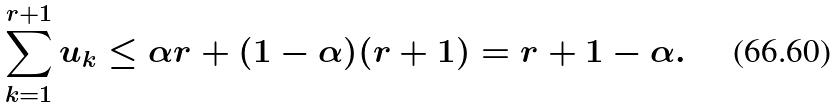Convert formula to latex. <formula><loc_0><loc_0><loc_500><loc_500>\sum _ { k = 1 } ^ { r + 1 } u _ { k } \leq \alpha r + ( 1 - \alpha ) ( r + 1 ) = r + 1 - \alpha .</formula> 